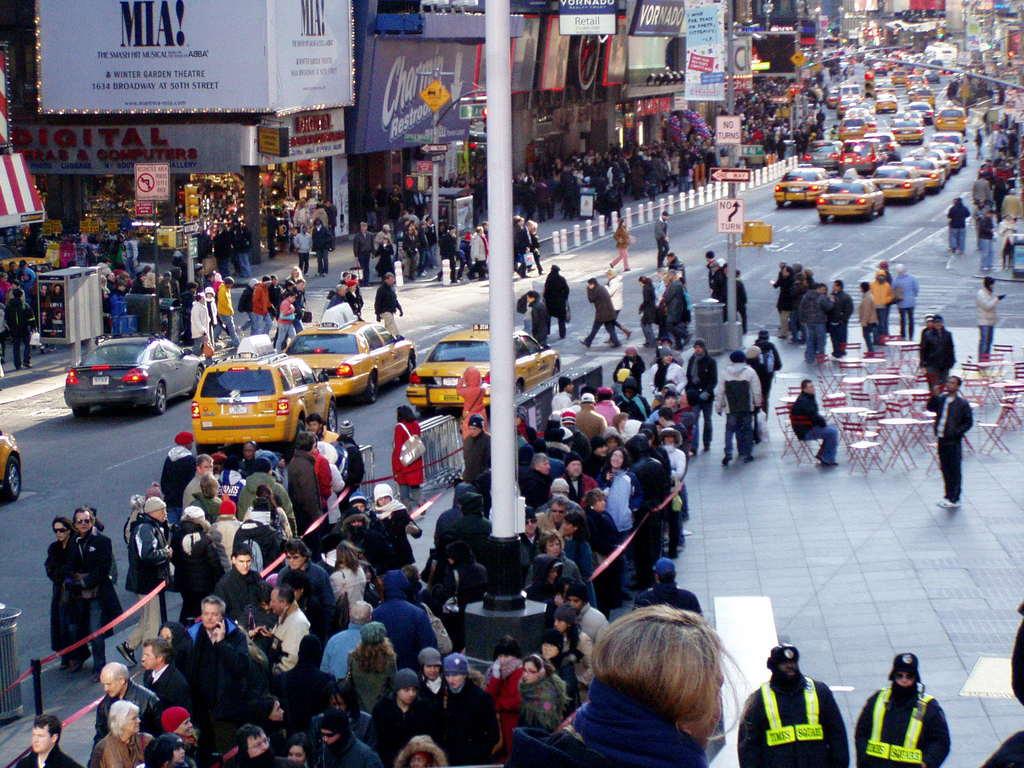What does it say on the white banner on the left?
Provide a short and direct response. Mia!. What is on the sign beneath the one way sign on the pole in the middle?
Keep it short and to the point. No turn. 